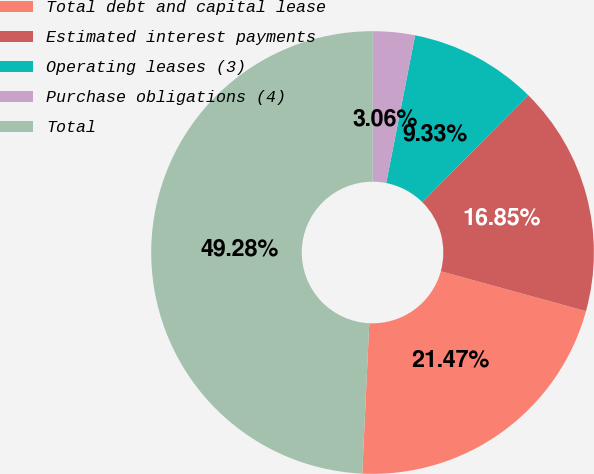Convert chart to OTSL. <chart><loc_0><loc_0><loc_500><loc_500><pie_chart><fcel>Total debt and capital lease<fcel>Estimated interest payments<fcel>Operating leases (3)<fcel>Purchase obligations (4)<fcel>Total<nl><fcel>21.47%<fcel>16.85%<fcel>9.33%<fcel>3.06%<fcel>49.27%<nl></chart> 